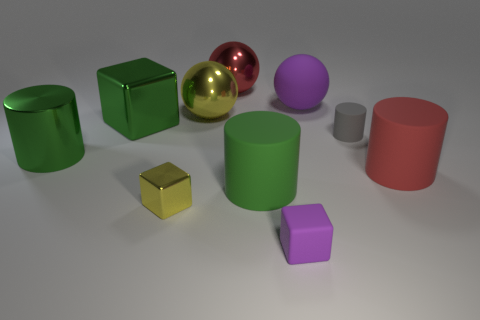There is a object that is the same color as the big matte ball; what is its size?
Ensure brevity in your answer.  Small. Is there a big rubber thing that has the same color as the tiny rubber cube?
Your answer should be compact. Yes. There is a large shiny cylinder; does it have the same color as the large rubber cylinder that is in front of the red matte object?
Offer a terse response. Yes. Does the metal ball on the left side of the red metal object have the same color as the small metallic thing?
Provide a succinct answer. Yes. How many other objects are the same shape as the large green matte thing?
Your answer should be very brief. 3. What shape is the big metallic thing behind the purple thing behind the small thing to the right of the purple matte block?
Provide a short and direct response. Sphere. What number of balls are big brown metal things or large yellow shiny things?
Keep it short and to the point. 1. There is a large red object in front of the gray cylinder; is there a big red matte cylinder behind it?
Make the answer very short. No. Do the big purple object and the small object on the left side of the red metallic object have the same shape?
Provide a short and direct response. No. How many other things are the same size as the green matte thing?
Your response must be concise. 6. 